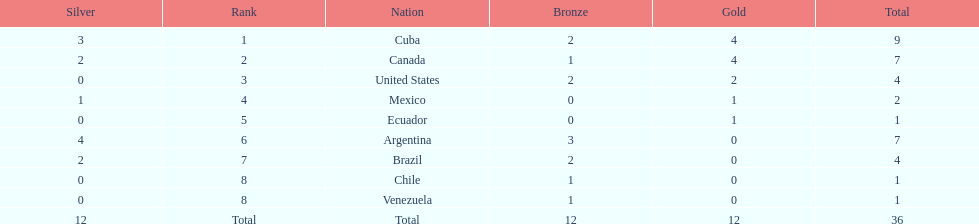Who had more silver medals, cuba or brazil? Cuba. 